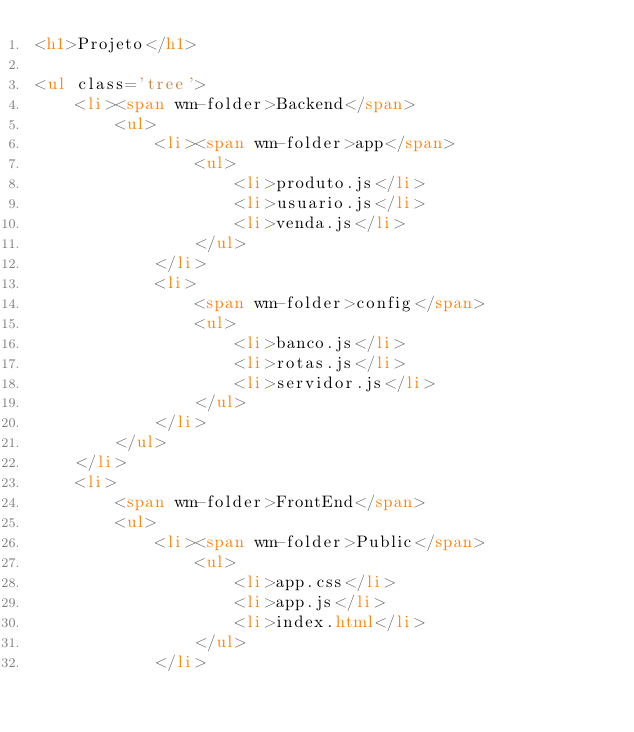<code> <loc_0><loc_0><loc_500><loc_500><_HTML_><h1>Projeto</h1>

<ul class='tree'>
    <li><span wm-folder>Backend</span>
        <ul>
            <li><span wm-folder>app</span>
                <ul>
                    <li>produto.js</li>
                    <li>usuario.js</li>
                    <li>venda.js</li>
                </ul>
            </li>
            <li>
                <span wm-folder>config</span>
                <ul>
                    <li>banco.js</li>
                    <li>rotas.js</li>
                    <li>servidor.js</li>
                </ul>
            </li>
        </ul>
    </li>
    <li>
        <span wm-folder>FrontEnd</span>
        <ul>
            <li><span wm-folder>Public</span>
                <ul>
                    <li>app.css</li>
                    <li>app.js</li>
                    <li>index.html</li>
                </ul>
            </li></code> 